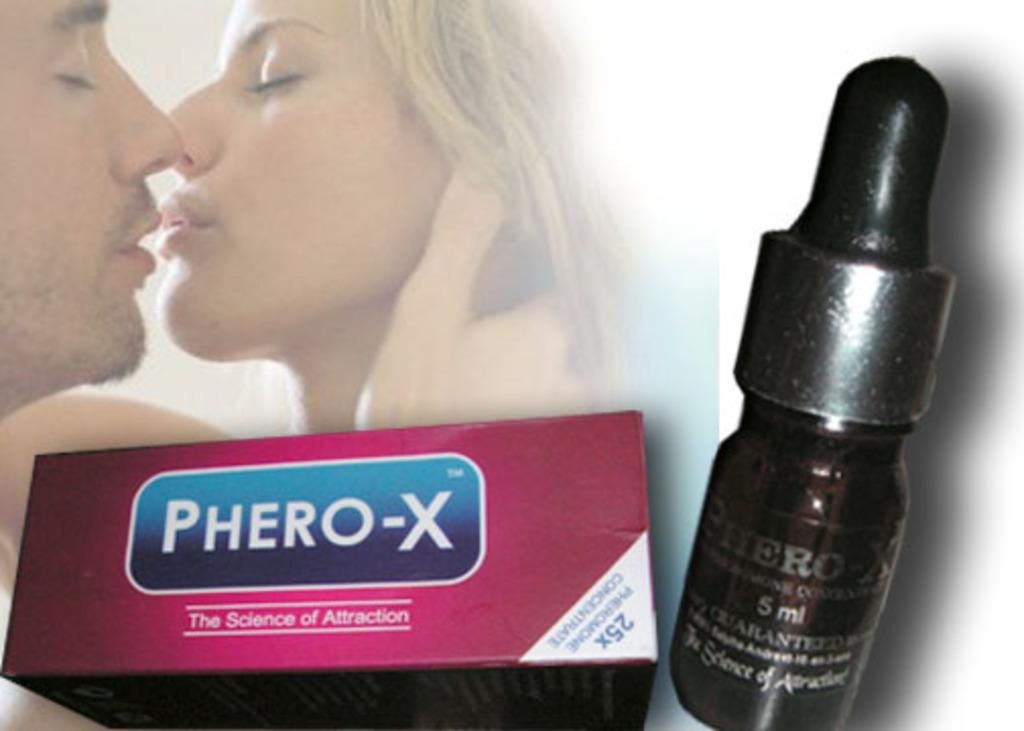What is depicted in the image? There is a poster in the image. What can be seen on the poster? There is a woman and a man in the poster. What colors are present at the bottom of the image? There is a pink color box and a black color bottle at the bottom of the image. What type of locket is the woman wearing in the image? There is no locket visible in the image; the woman is depicted on a poster. What brand of jeans is the man wearing in the image? There is no information about the man's clothing in the image, as it only shows a poster with a woman and a man. 